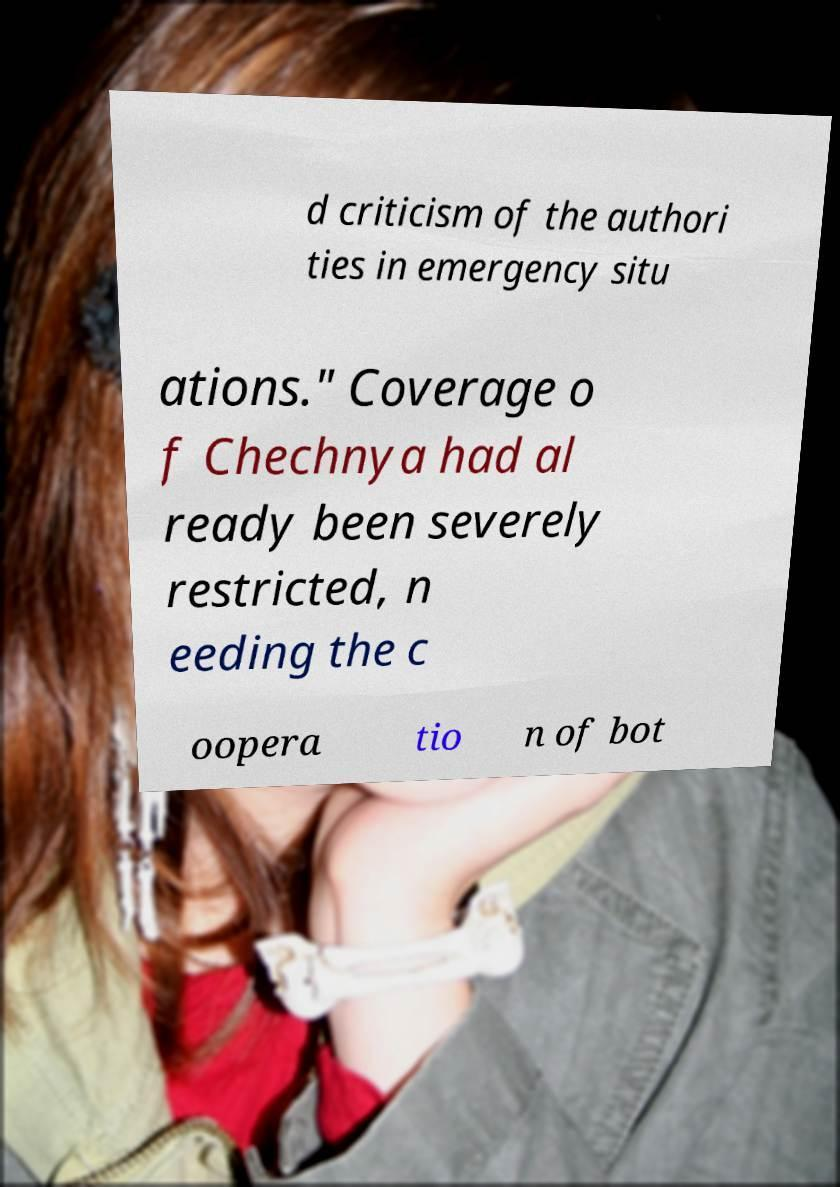Could you assist in decoding the text presented in this image and type it out clearly? d criticism of the authori ties in emergency situ ations." Coverage o f Chechnya had al ready been severely restricted, n eeding the c oopera tio n of bot 